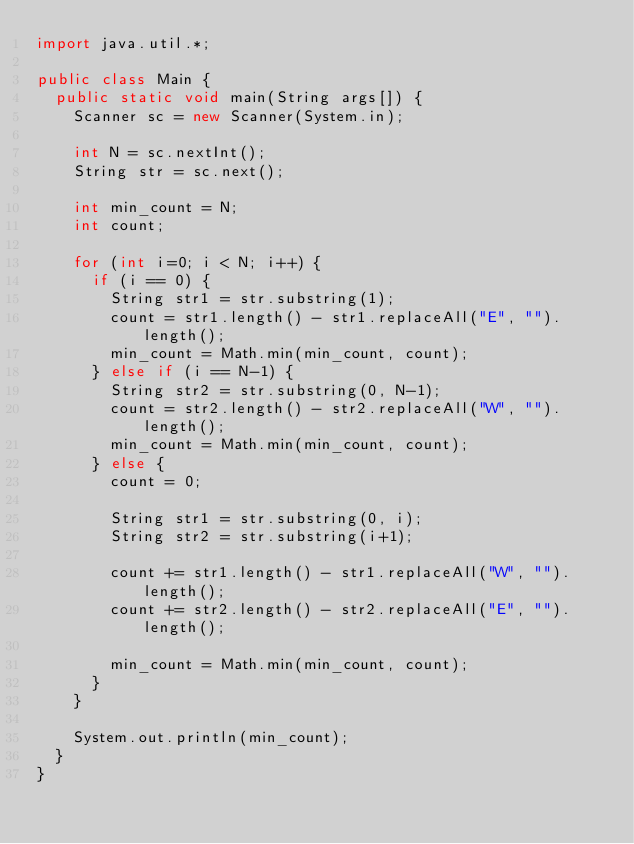<code> <loc_0><loc_0><loc_500><loc_500><_Java_>import java.util.*;

public class Main {
  public static void main(String args[]) {
    Scanner sc = new Scanner(System.in);

    int N = sc.nextInt();
    String str = sc.next();

    int min_count = N;
    int count;

    for (int i=0; i < N; i++) {
      if (i == 0) {
        String str1 = str.substring(1);
        count = str1.length() - str1.replaceAll("E", "").length();
        min_count = Math.min(min_count, count);
      } else if (i == N-1) {
        String str2 = str.substring(0, N-1);
        count = str2.length() - str2.replaceAll("W", "").length();
        min_count = Math.min(min_count, count);
      } else {
        count = 0;

        String str1 = str.substring(0, i);
        String str2 = str.substring(i+1);

        count += str1.length() - str1.replaceAll("W", "").length();
        count += str2.length() - str2.replaceAll("E", "").length();

        min_count = Math.min(min_count, count);
      }
    }

    System.out.println(min_count);
  }
}
</code> 